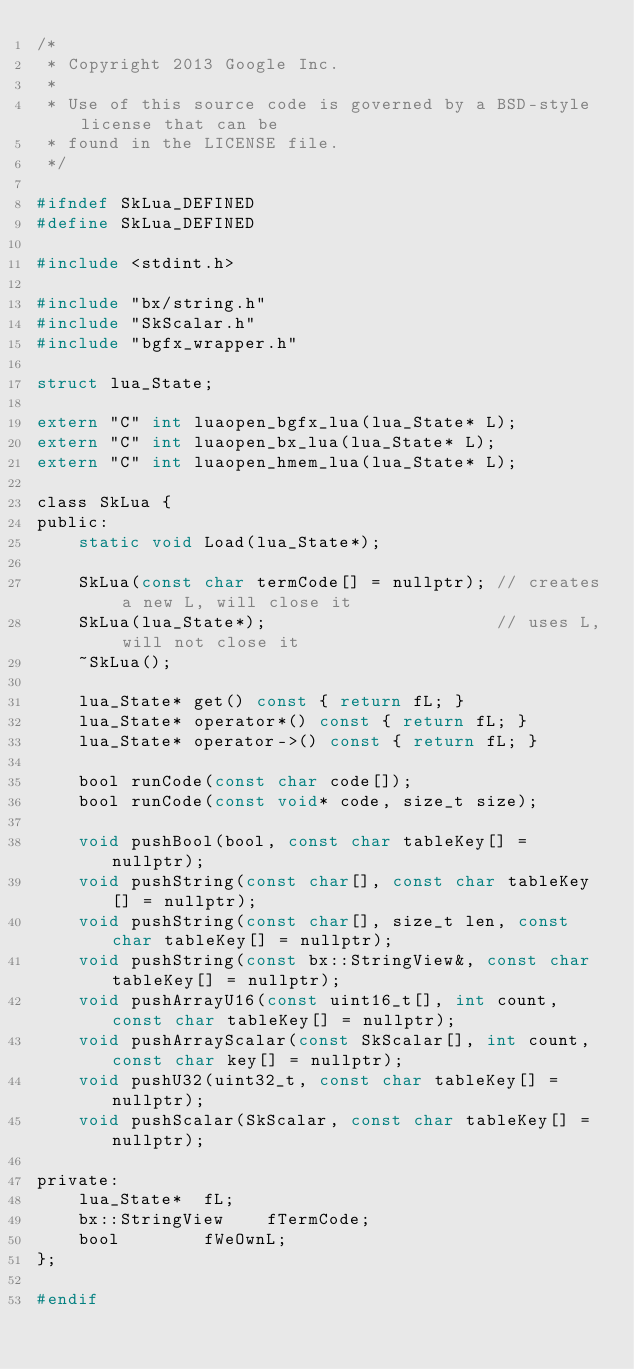Convert code to text. <code><loc_0><loc_0><loc_500><loc_500><_C_>/*
 * Copyright 2013 Google Inc.
 *
 * Use of this source code is governed by a BSD-style license that can be
 * found in the LICENSE file.
 */

#ifndef SkLua_DEFINED
#define SkLua_DEFINED

#include <stdint.h>

#include "bx/string.h"
#include "SkScalar.h"
#include "bgfx_wrapper.h"

struct lua_State;

extern "C" int luaopen_bgfx_lua(lua_State* L);
extern "C" int luaopen_bx_lua(lua_State* L);
extern "C" int luaopen_hmem_lua(lua_State* L);

class SkLua {
public:
    static void Load(lua_State*);

    SkLua(const char termCode[] = nullptr); // creates a new L, will close it
    SkLua(lua_State*);                      // uses L, will not close it
    ~SkLua();

    lua_State* get() const { return fL; }
    lua_State* operator*() const { return fL; }
    lua_State* operator->() const { return fL; }

    bool runCode(const char code[]);
    bool runCode(const void* code, size_t size);

    void pushBool(bool, const char tableKey[] = nullptr);
    void pushString(const char[], const char tableKey[] = nullptr);
    void pushString(const char[], size_t len, const char tableKey[] = nullptr);
    void pushString(const bx::StringView&, const char tableKey[] = nullptr);
    void pushArrayU16(const uint16_t[], int count, const char tableKey[] = nullptr);
    void pushArrayScalar(const SkScalar[], int count, const char key[] = nullptr);
    void pushU32(uint32_t, const char tableKey[] = nullptr);
    void pushScalar(SkScalar, const char tableKey[] = nullptr);

private:
    lua_State*  fL;
    bx::StringView    fTermCode;
    bool        fWeOwnL;
};

#endif
</code> 